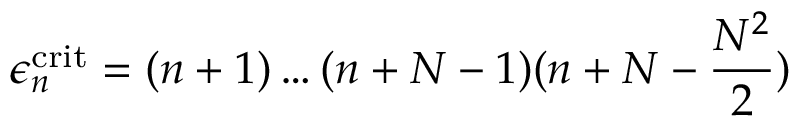<formula> <loc_0><loc_0><loc_500><loc_500>\epsilon _ { n } ^ { c r i t } = ( n + 1 ) \dots ( n + N - 1 ) ( n + N - \frac { N ^ { 2 } } { 2 } )</formula> 